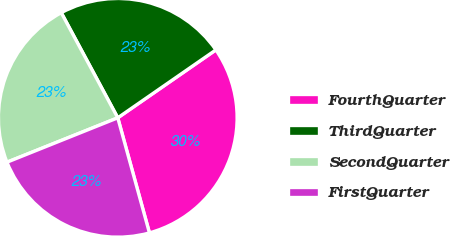<chart> <loc_0><loc_0><loc_500><loc_500><pie_chart><fcel>FourthQuarter<fcel>ThirdQuarter<fcel>SecondQuarter<fcel>FirstQuarter<nl><fcel>30.36%<fcel>23.21%<fcel>23.21%<fcel>23.21%<nl></chart> 